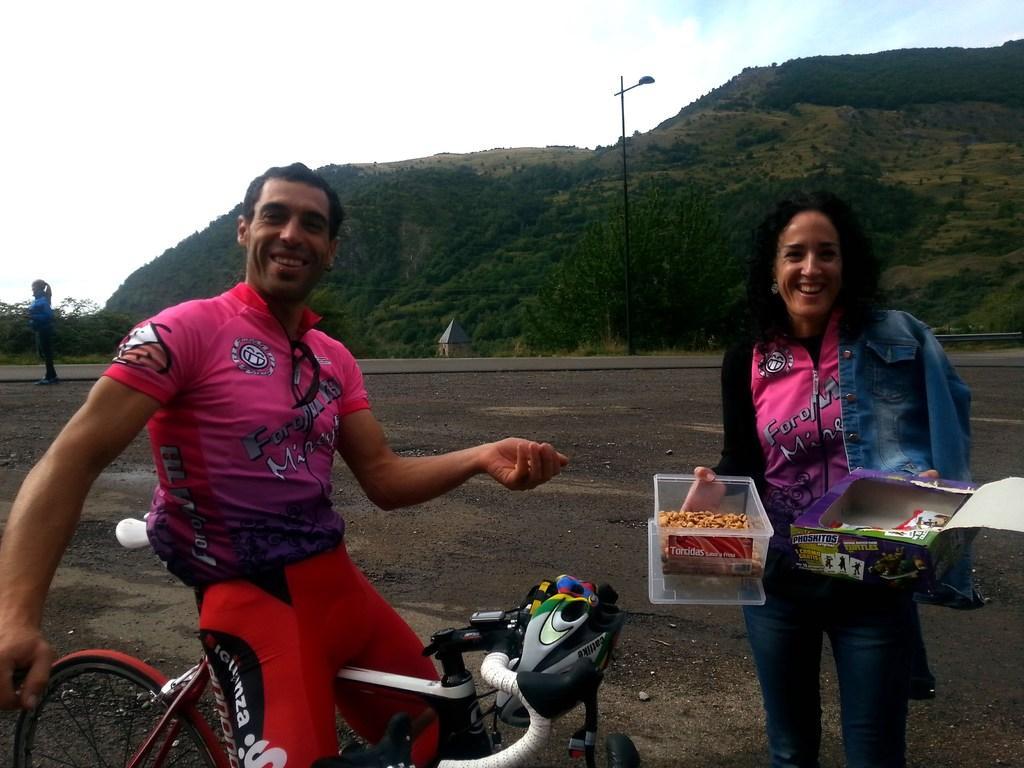How would you summarize this image in a sentence or two? This picture is clicked outside. On the left there is a man wearing pink color t-shirt, smiling and sitting on a bicycle. On the right there is a woman holding boxes, smiling and standing on the ground. In the background we can see the sky, hills, trees, pole and a person standing on the ground. 